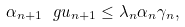Convert formula to latex. <formula><loc_0><loc_0><loc_500><loc_500>\alpha _ { n + 1 } \ g u _ { n + 1 } \leq \lambda _ { n } \alpha _ { n } \gamma _ { n } ,</formula> 